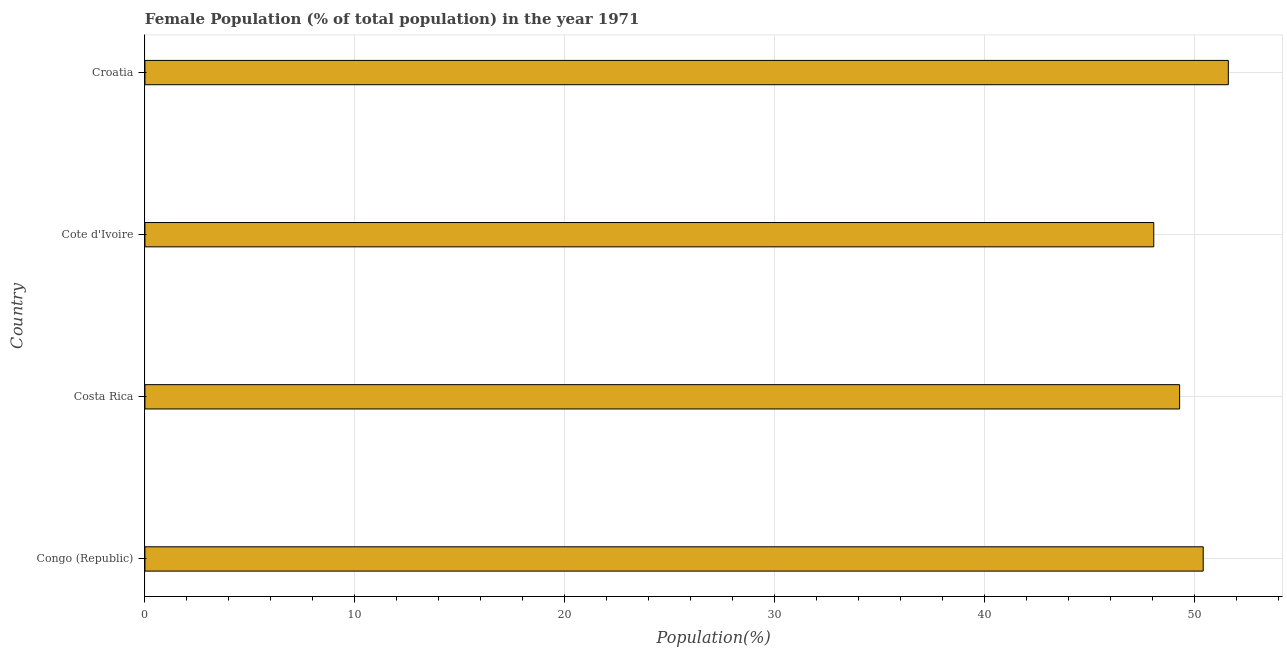Does the graph contain any zero values?
Ensure brevity in your answer.  No. What is the title of the graph?
Give a very brief answer. Female Population (% of total population) in the year 1971. What is the label or title of the X-axis?
Offer a terse response. Population(%). What is the label or title of the Y-axis?
Ensure brevity in your answer.  Country. What is the female population in Congo (Republic)?
Make the answer very short. 50.4. Across all countries, what is the maximum female population?
Ensure brevity in your answer.  51.59. Across all countries, what is the minimum female population?
Your answer should be very brief. 48.04. In which country was the female population maximum?
Provide a short and direct response. Croatia. In which country was the female population minimum?
Offer a terse response. Cote d'Ivoire. What is the sum of the female population?
Your answer should be very brief. 199.3. What is the difference between the female population in Congo (Republic) and Cote d'Ivoire?
Your answer should be very brief. 2.35. What is the average female population per country?
Give a very brief answer. 49.83. What is the median female population?
Offer a terse response. 49.83. What is the ratio of the female population in Costa Rica to that in Croatia?
Keep it short and to the point. 0.95. Is the female population in Costa Rica less than that in Cote d'Ivoire?
Offer a terse response. No. Is the difference between the female population in Congo (Republic) and Croatia greater than the difference between any two countries?
Your response must be concise. No. What is the difference between the highest and the second highest female population?
Give a very brief answer. 1.2. What is the difference between the highest and the lowest female population?
Your answer should be very brief. 3.55. What is the difference between two consecutive major ticks on the X-axis?
Offer a very short reply. 10. Are the values on the major ticks of X-axis written in scientific E-notation?
Your response must be concise. No. What is the Population(%) in Congo (Republic)?
Offer a terse response. 50.4. What is the Population(%) in Costa Rica?
Keep it short and to the point. 49.27. What is the Population(%) in Cote d'Ivoire?
Your answer should be very brief. 48.04. What is the Population(%) in Croatia?
Make the answer very short. 51.59. What is the difference between the Population(%) in Congo (Republic) and Costa Rica?
Provide a succinct answer. 1.12. What is the difference between the Population(%) in Congo (Republic) and Cote d'Ivoire?
Offer a terse response. 2.35. What is the difference between the Population(%) in Congo (Republic) and Croatia?
Offer a very short reply. -1.2. What is the difference between the Population(%) in Costa Rica and Cote d'Ivoire?
Provide a short and direct response. 1.23. What is the difference between the Population(%) in Costa Rica and Croatia?
Offer a very short reply. -2.32. What is the difference between the Population(%) in Cote d'Ivoire and Croatia?
Your answer should be compact. -3.55. What is the ratio of the Population(%) in Congo (Republic) to that in Costa Rica?
Your response must be concise. 1.02. What is the ratio of the Population(%) in Congo (Republic) to that in Cote d'Ivoire?
Ensure brevity in your answer.  1.05. What is the ratio of the Population(%) in Costa Rica to that in Cote d'Ivoire?
Your response must be concise. 1.03. What is the ratio of the Population(%) in Costa Rica to that in Croatia?
Ensure brevity in your answer.  0.95. What is the ratio of the Population(%) in Cote d'Ivoire to that in Croatia?
Your response must be concise. 0.93. 